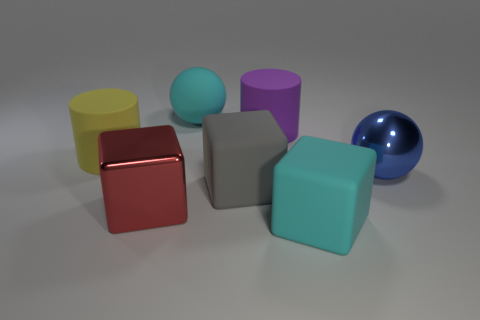Subtract all gray balls. Subtract all brown cylinders. How many balls are left? 2 Add 1 large cyan matte blocks. How many objects exist? 8 Subtract all blocks. How many objects are left? 4 Add 7 small gray metallic balls. How many small gray metallic balls exist? 7 Subtract 0 brown cylinders. How many objects are left? 7 Subtract all cyan rubber spheres. Subtract all large brown rubber objects. How many objects are left? 6 Add 4 big yellow matte things. How many big yellow matte things are left? 5 